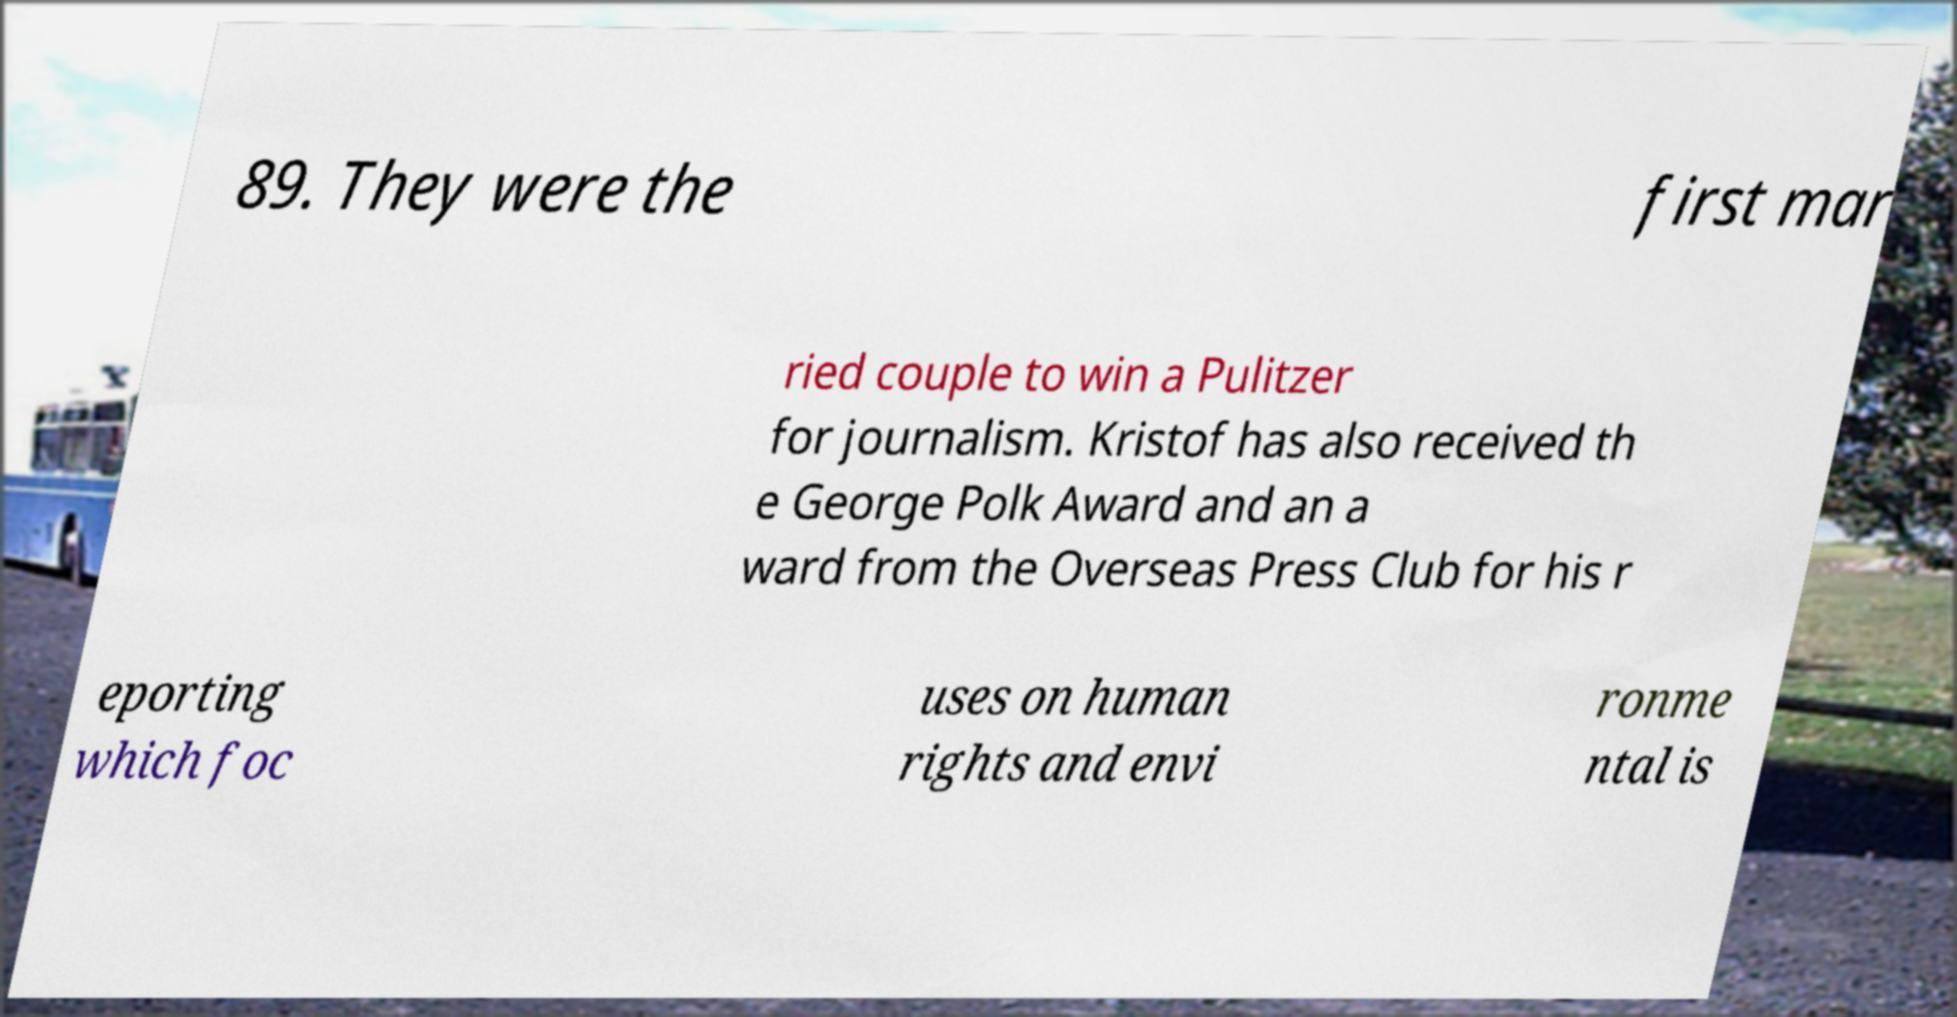What messages or text are displayed in this image? I need them in a readable, typed format. 89. They were the first mar ried couple to win a Pulitzer for journalism. Kristof has also received th e George Polk Award and an a ward from the Overseas Press Club for his r eporting which foc uses on human rights and envi ronme ntal is 